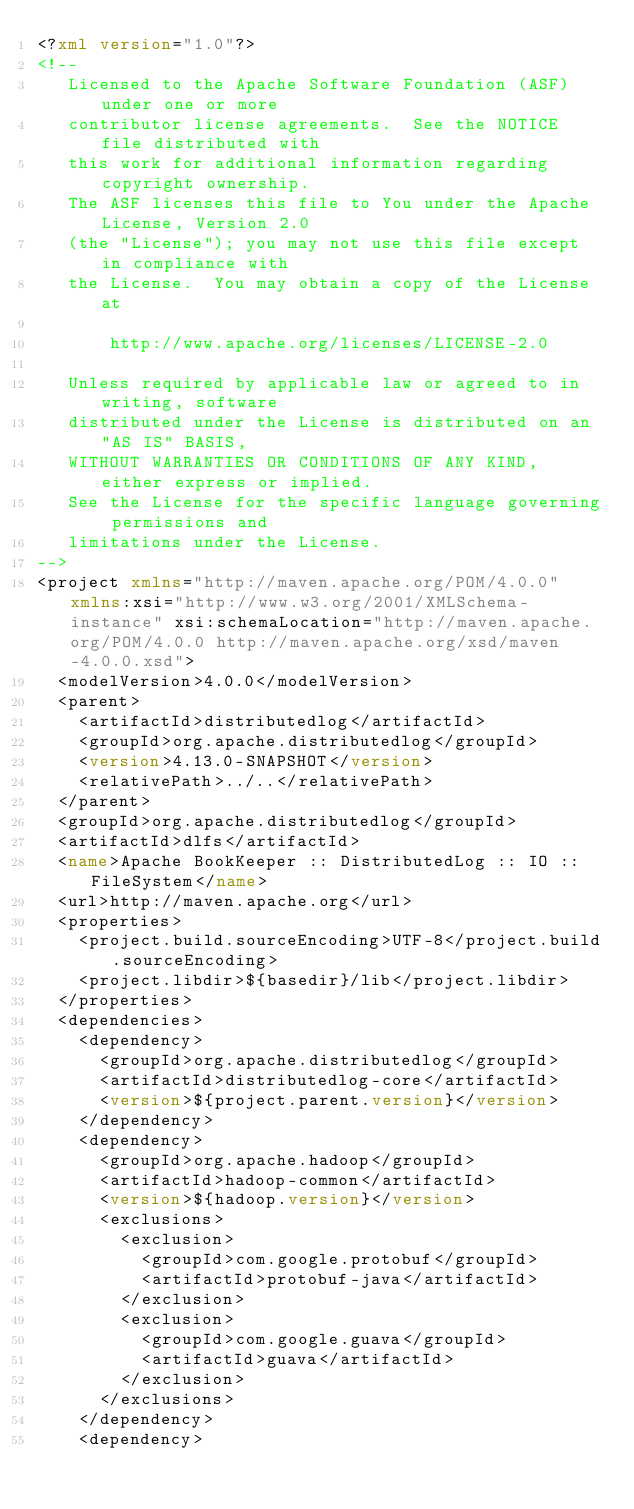<code> <loc_0><loc_0><loc_500><loc_500><_XML_><?xml version="1.0"?>
<!--
   Licensed to the Apache Software Foundation (ASF) under one or more
   contributor license agreements.  See the NOTICE file distributed with
   this work for additional information regarding copyright ownership.
   The ASF licenses this file to You under the Apache License, Version 2.0
   (the "License"); you may not use this file except in compliance with
   the License.  You may obtain a copy of the License at

       http://www.apache.org/licenses/LICENSE-2.0

   Unless required by applicable law or agreed to in writing, software
   distributed under the License is distributed on an "AS IS" BASIS,
   WITHOUT WARRANTIES OR CONDITIONS OF ANY KIND, either express or implied.
   See the License for the specific language governing permissions and
   limitations under the License.
-->
<project xmlns="http://maven.apache.org/POM/4.0.0" xmlns:xsi="http://www.w3.org/2001/XMLSchema-instance" xsi:schemaLocation="http://maven.apache.org/POM/4.0.0 http://maven.apache.org/xsd/maven-4.0.0.xsd">
  <modelVersion>4.0.0</modelVersion>
  <parent>
    <artifactId>distributedlog</artifactId>
    <groupId>org.apache.distributedlog</groupId>
    <version>4.13.0-SNAPSHOT</version>
    <relativePath>../..</relativePath>
  </parent>
  <groupId>org.apache.distributedlog</groupId>
  <artifactId>dlfs</artifactId>
  <name>Apache BookKeeper :: DistributedLog :: IO :: FileSystem</name>
  <url>http://maven.apache.org</url>
  <properties>
    <project.build.sourceEncoding>UTF-8</project.build.sourceEncoding>
    <project.libdir>${basedir}/lib</project.libdir>
  </properties>
  <dependencies>
    <dependency>
      <groupId>org.apache.distributedlog</groupId>
      <artifactId>distributedlog-core</artifactId>
      <version>${project.parent.version}</version>
    </dependency>
    <dependency>
      <groupId>org.apache.hadoop</groupId>
      <artifactId>hadoop-common</artifactId>
      <version>${hadoop.version}</version>
      <exclusions>
        <exclusion>
          <groupId>com.google.protobuf</groupId>
          <artifactId>protobuf-java</artifactId>
        </exclusion>
        <exclusion>
          <groupId>com.google.guava</groupId>
          <artifactId>guava</artifactId>
        </exclusion>
      </exclusions>
    </dependency>
    <dependency></code> 